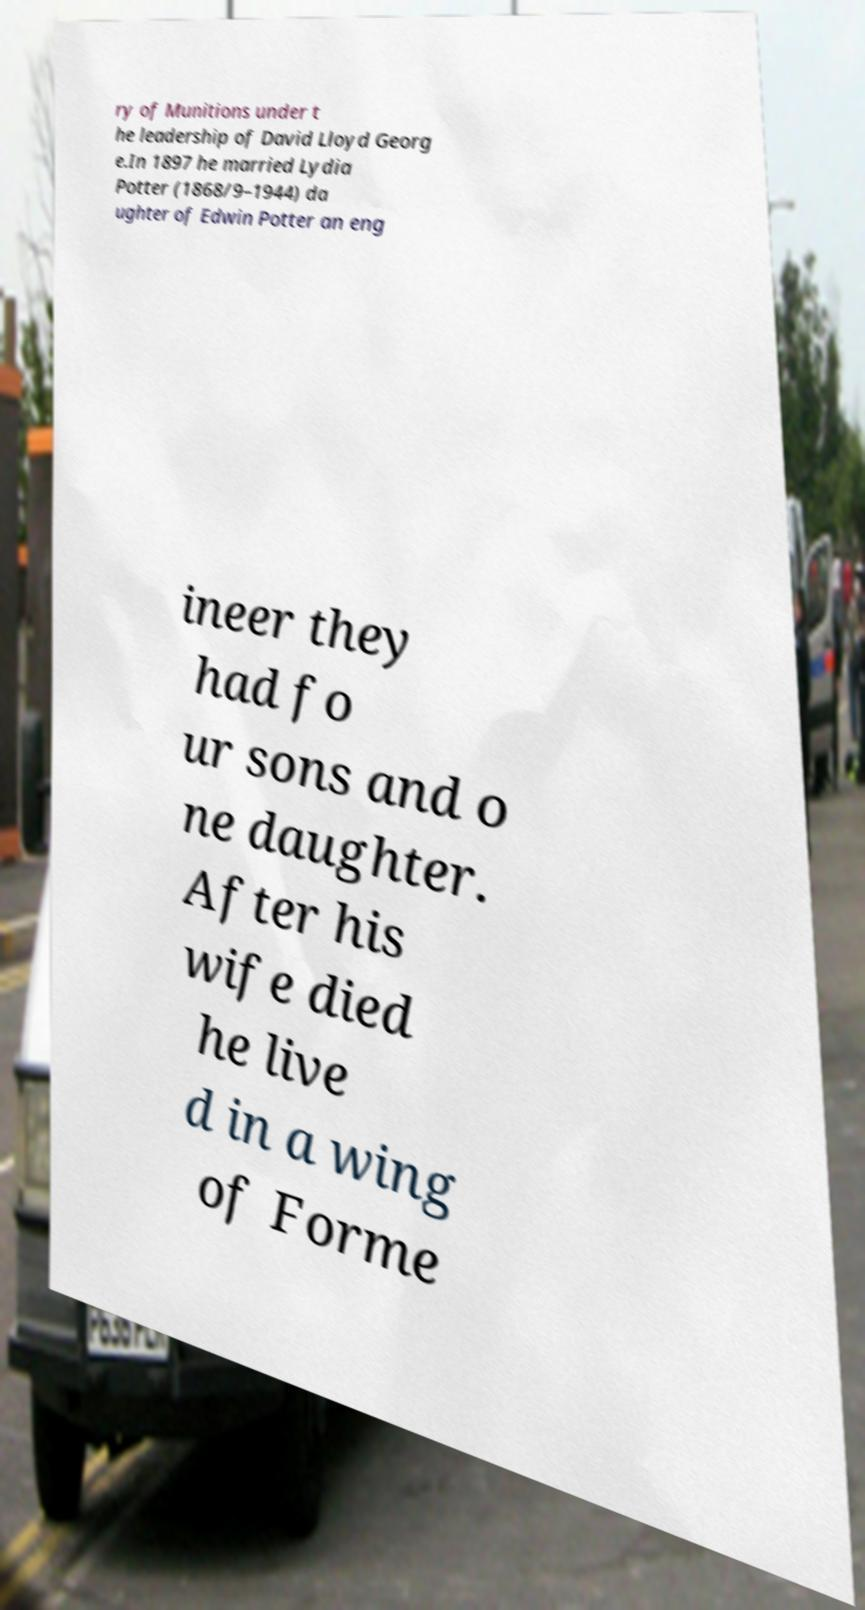There's text embedded in this image that I need extracted. Can you transcribe it verbatim? ry of Munitions under t he leadership of David Lloyd Georg e.In 1897 he married Lydia Potter (1868/9–1944) da ughter of Edwin Potter an eng ineer they had fo ur sons and o ne daughter. After his wife died he live d in a wing of Forme 